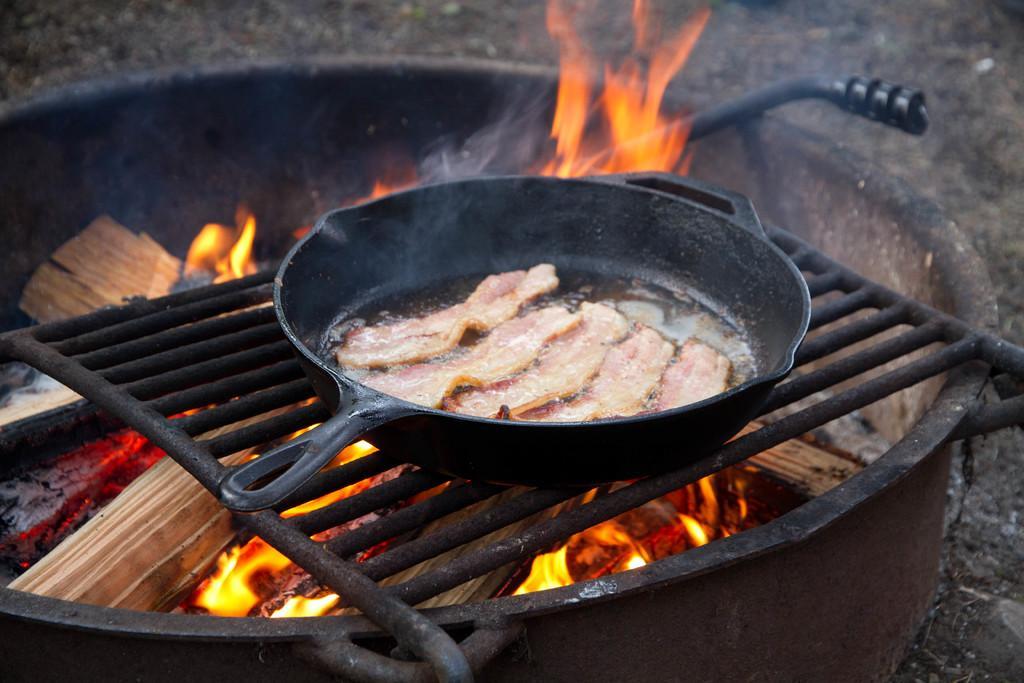Describe this image in one or two sentences. In this image we can see a vessel with fire. There is a grill on which there are food items in a bowl. 